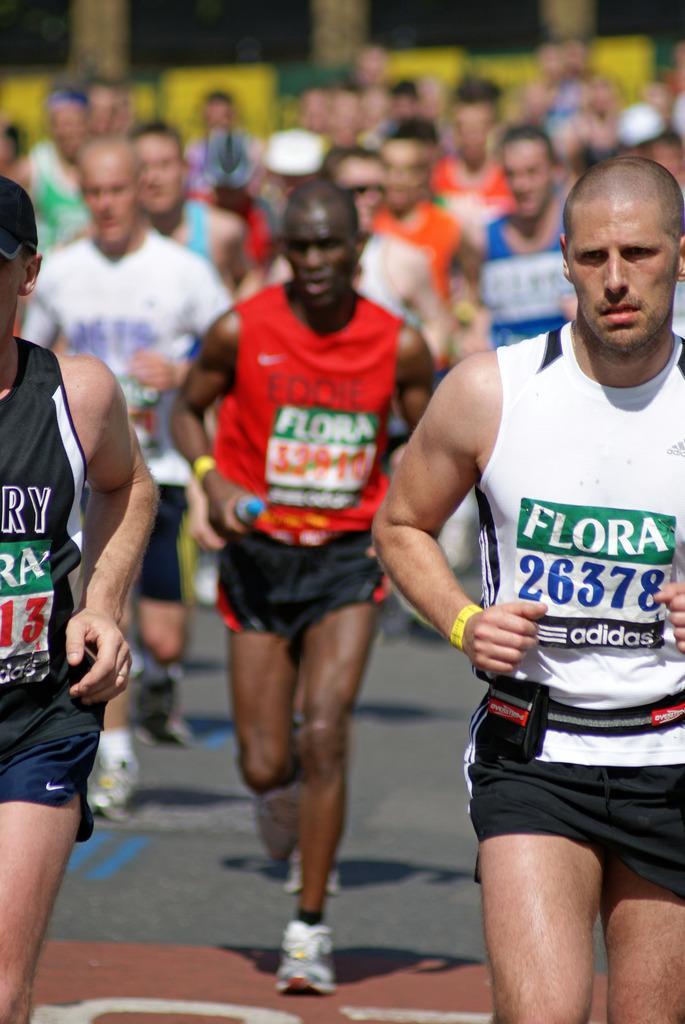<image>
Summarize the visual content of the image. People running in a marathon with the print  Flora on their shirts. 